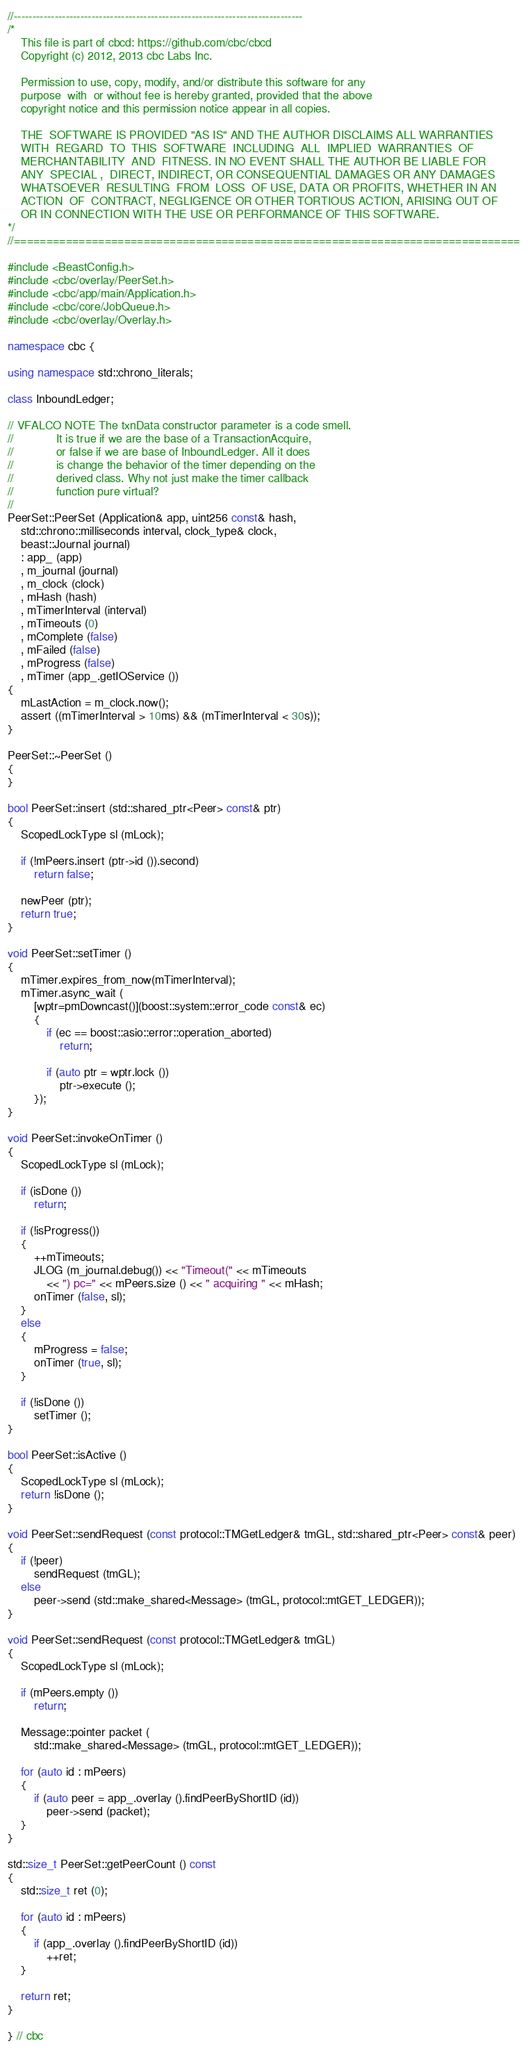<code> <loc_0><loc_0><loc_500><loc_500><_C++_>//------------------------------------------------------------------------------
/*
    This file is part of cbcd: https://github.com/cbc/cbcd
    Copyright (c) 2012, 2013 cbc Labs Inc.

    Permission to use, copy, modify, and/or distribute this software for any
    purpose  with  or without fee is hereby granted, provided that the above
    copyright notice and this permission notice appear in all copies.

    THE  SOFTWARE IS PROVIDED "AS IS" AND THE AUTHOR DISCLAIMS ALL WARRANTIES
    WITH  REGARD  TO  THIS  SOFTWARE  INCLUDING  ALL  IMPLIED  WARRANTIES  OF
    MERCHANTABILITY  AND  FITNESS. IN NO EVENT SHALL THE AUTHOR BE LIABLE FOR
    ANY  SPECIAL ,  DIRECT, INDIRECT, OR CONSEQUENTIAL DAMAGES OR ANY DAMAGES
    WHATSOEVER  RESULTING  FROM  LOSS  OF USE, DATA OR PROFITS, WHETHER IN AN
    ACTION  OF  CONTRACT, NEGLIGENCE OR OTHER TORTIOUS ACTION, ARISING OUT OF
    OR IN CONNECTION WITH THE USE OR PERFORMANCE OF THIS SOFTWARE.
*/
//==============================================================================

#include <BeastConfig.h>
#include <cbc/overlay/PeerSet.h>
#include <cbc/app/main/Application.h>
#include <cbc/core/JobQueue.h>
#include <cbc/overlay/Overlay.h>

namespace cbc {

using namespace std::chrono_literals;

class InboundLedger;

// VFALCO NOTE The txnData constructor parameter is a code smell.
//             It is true if we are the base of a TransactionAcquire,
//             or false if we are base of InboundLedger. All it does
//             is change the behavior of the timer depending on the
//             derived class. Why not just make the timer callback
//             function pure virtual?
//
PeerSet::PeerSet (Application& app, uint256 const& hash,
    std::chrono::milliseconds interval, clock_type& clock,
    beast::Journal journal)
    : app_ (app)
    , m_journal (journal)
    , m_clock (clock)
    , mHash (hash)
    , mTimerInterval (interval)
    , mTimeouts (0)
    , mComplete (false)
    , mFailed (false)
    , mProgress (false)
    , mTimer (app_.getIOService ())
{
    mLastAction = m_clock.now();
    assert ((mTimerInterval > 10ms) && (mTimerInterval < 30s));
}

PeerSet::~PeerSet ()
{
}

bool PeerSet::insert (std::shared_ptr<Peer> const& ptr)
{
    ScopedLockType sl (mLock);

    if (!mPeers.insert (ptr->id ()).second)
        return false;

    newPeer (ptr);
    return true;
}

void PeerSet::setTimer ()
{
    mTimer.expires_from_now(mTimerInterval);
    mTimer.async_wait (
        [wptr=pmDowncast()](boost::system::error_code const& ec)
        {
            if (ec == boost::asio::error::operation_aborted)
                return;

            if (auto ptr = wptr.lock ())
                ptr->execute ();
        });
}

void PeerSet::invokeOnTimer ()
{
    ScopedLockType sl (mLock);

    if (isDone ())
        return;

    if (!isProgress())
    {
        ++mTimeouts;
        JLOG (m_journal.debug()) << "Timeout(" << mTimeouts
            << ") pc=" << mPeers.size () << " acquiring " << mHash;
        onTimer (false, sl);
    }
    else
    {
        mProgress = false;
        onTimer (true, sl);
    }

    if (!isDone ())
        setTimer ();
}

bool PeerSet::isActive ()
{
    ScopedLockType sl (mLock);
    return !isDone ();
}

void PeerSet::sendRequest (const protocol::TMGetLedger& tmGL, std::shared_ptr<Peer> const& peer)
{
    if (!peer)
        sendRequest (tmGL);
    else
        peer->send (std::make_shared<Message> (tmGL, protocol::mtGET_LEDGER));
}

void PeerSet::sendRequest (const protocol::TMGetLedger& tmGL)
{
    ScopedLockType sl (mLock);

    if (mPeers.empty ())
        return;

    Message::pointer packet (
        std::make_shared<Message> (tmGL, protocol::mtGET_LEDGER));

    for (auto id : mPeers)
    {
        if (auto peer = app_.overlay ().findPeerByShortID (id))
            peer->send (packet);
    }
}

std::size_t PeerSet::getPeerCount () const
{
    std::size_t ret (0);

    for (auto id : mPeers)
    {
        if (app_.overlay ().findPeerByShortID (id))
            ++ret;
    }

    return ret;
}

} // cbc
</code> 